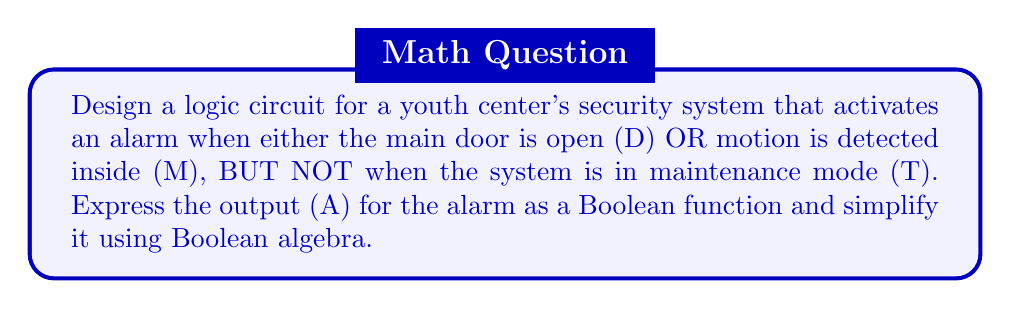Solve this math problem. Let's approach this step-by-step:

1) First, we need to express the alarm condition in words:
   Alarm = (Door open OR Motion detected) AND NOT Maintenance mode

2) Now, let's translate this into a Boolean function:
   $A = (D \lor M) \land \overline{T}$

3) To simplify this, we can use the distributive law:
   $A = (D \land \overline{T}) \lor (M \land \overline{T})$

4) This is already in its simplest form, as we can't combine these terms further.

5) To create a logic circuit for this function, we need:
   - An OR gate for $(D \lor M)$
   - An inverter (NOT gate) for $\overline{T}$
   - An AND gate to combine $(D \lor M)$ with $\overline{T}$

The logic circuit would look like this:

[asy]
import geometry;

pair A=(0,0), B=(0,30), C=(50,15), D=(100,15), E=(150,15);
draw(A--C--B);
draw(C--D);
draw(circle(D,5));
draw(D--E);

label("D", A, W);
label("M", B, W);
label("T", (75,30), N);
label("A", E, E);

label("OR", (25,15), S);
label("AND", (125,15), S);
[/asy]

This circuit implements the Boolean function $A = (D \lor M) \land \overline{T}$.
Answer: $A = (D \land \overline{T}) \lor (M \land \overline{T})$ 